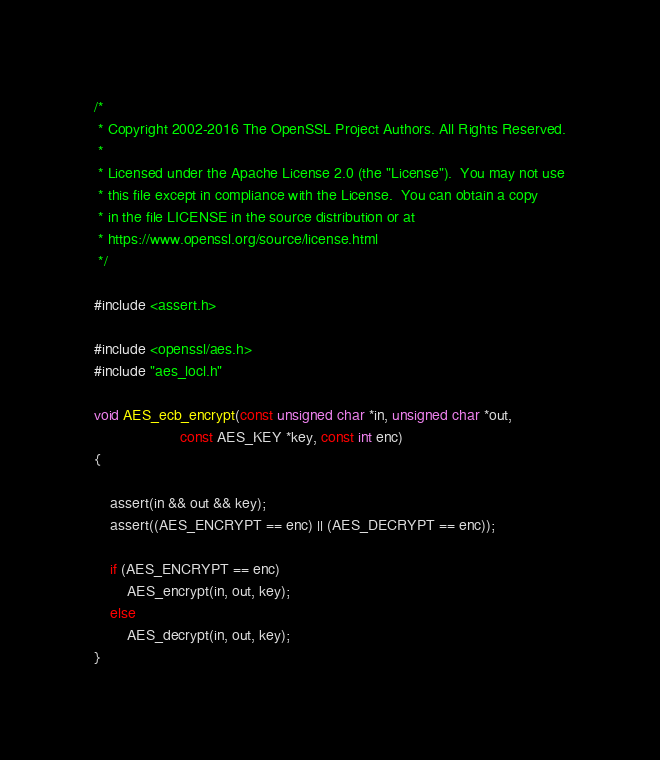<code> <loc_0><loc_0><loc_500><loc_500><_C_>/*
 * Copyright 2002-2016 The OpenSSL Project Authors. All Rights Reserved.
 *
 * Licensed under the Apache License 2.0 (the "License").  You may not use
 * this file except in compliance with the License.  You can obtain a copy
 * in the file LICENSE in the source distribution or at
 * https://www.openssl.org/source/license.html
 */

#include <assert.h>

#include <openssl/aes.h>
#include "aes_locl.h"

void AES_ecb_encrypt(const unsigned char *in, unsigned char *out,
                     const AES_KEY *key, const int enc)
{

    assert(in && out && key);
    assert((AES_ENCRYPT == enc) || (AES_DECRYPT == enc));

    if (AES_ENCRYPT == enc)
        AES_encrypt(in, out, key);
    else
        AES_decrypt(in, out, key);
}
</code> 